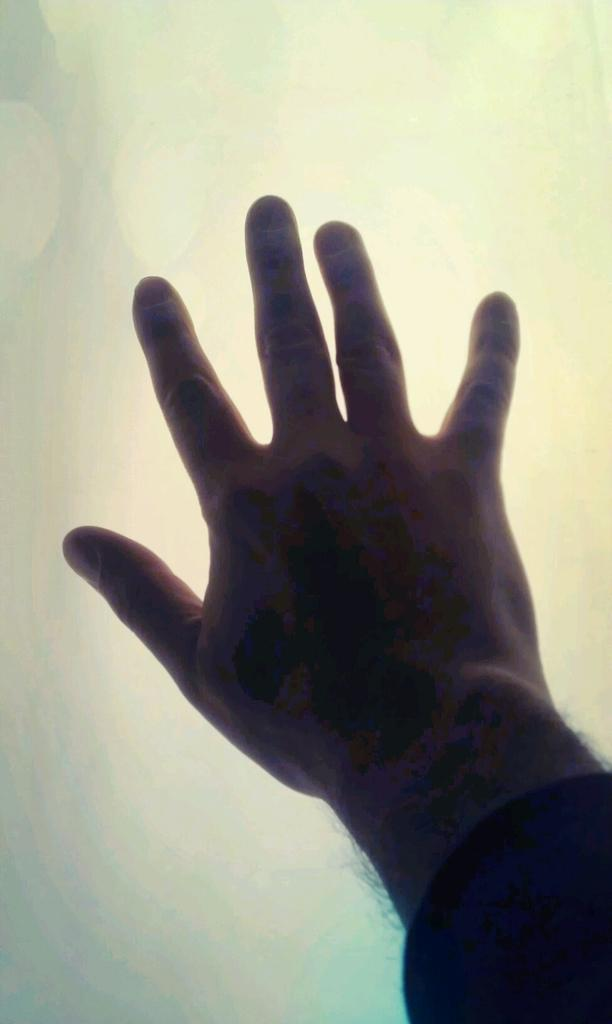What part of the human body is visible in the image? There is a human hand in the image. Can you describe the background of the image? The background of the image is blurry. What type of cheese is being grated by the hand in the image? There is no cheese present in the image, and the hand is not performing any action like grating. 